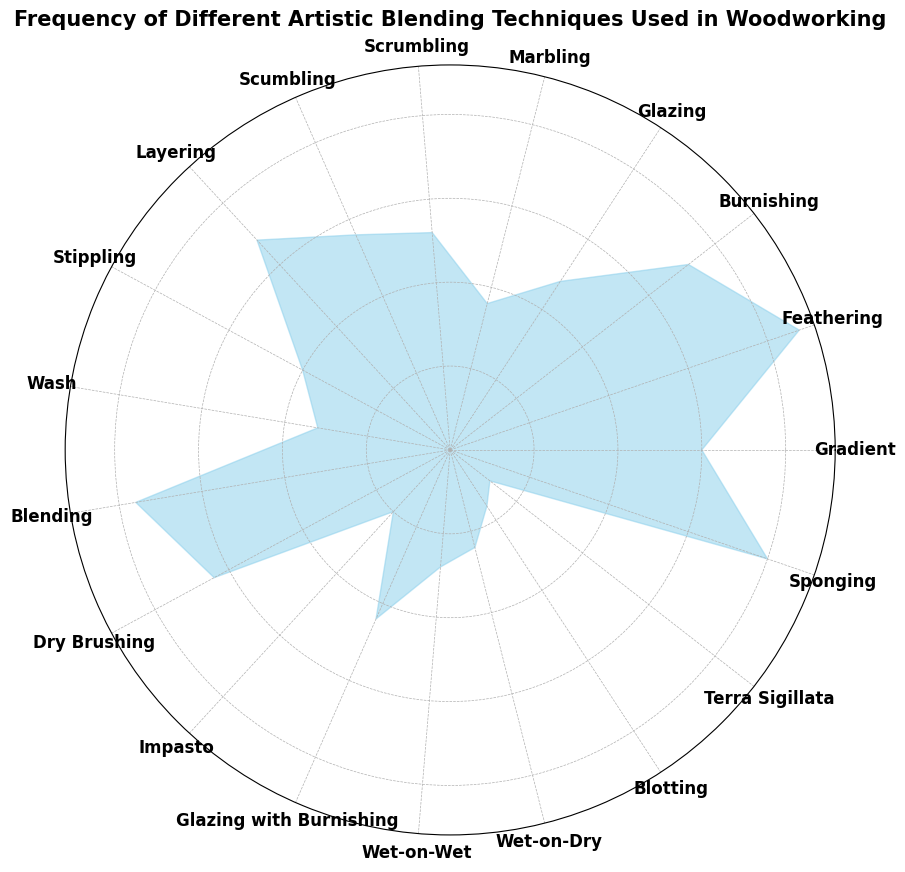Which artistic blending technique has the highest frequency? The highest bar represents the technique with the most frequency. From the chart, "Feathering" has the highest bar.
Answer: Feathering Which technique has a lower frequency, Scumbling or Wash? Compare the heights of the bars for "Scumbling" and "Wash". "Wash" has a lower bar height.
Answer: Wash What's the combined frequency of Gradient and Dry Brushing techniques? The frequencies for "Gradient" and "Dry Brushing" are 15 and 16, respectively. Adding these together gives 15 + 16 = 31.
Answer: 31 What is the average frequency of the four highest frequency techniques? First, identify the four highest frequencies: 22 (Feathering), 20 (Sponging), 19 (Blending), and 18 (Burnishing). Then, calculate the average: (22 + 20 + 19 + 18) / 4 = 79 / 4 = 19.75.
Answer: 19.75 What's the combined frequency of the three techniques with the lowest frequency? The frequencies for the three techniques with the lowest counts are: 3 (Terra Sigillata), 4 (Blotting), and 5 (Impasto). Adding these together gives: 3 + 4 + 5 = 12.
Answer: 12 Which technique has a bar color different from others? From the chart, all bars appear to have the same color "skyblue". No technique has a different bar color.
Answer: None How many techniques have a frequency less than 10? Count the bars with heights representing frequencies less than 10. These techniques are: Wash, Wet-on-Wet, Wet-on-Dry, Blotting, Terra Sigillata, Marbling, and Impasto, totaling 7 techniques.
Answer: 7 Which technique is represented by the bar directly to the right of "Gradient"? By visually locating "Gradient" on the chart, the bar directly to the right represents "Scrumbling".
Answer: Scrumbling 